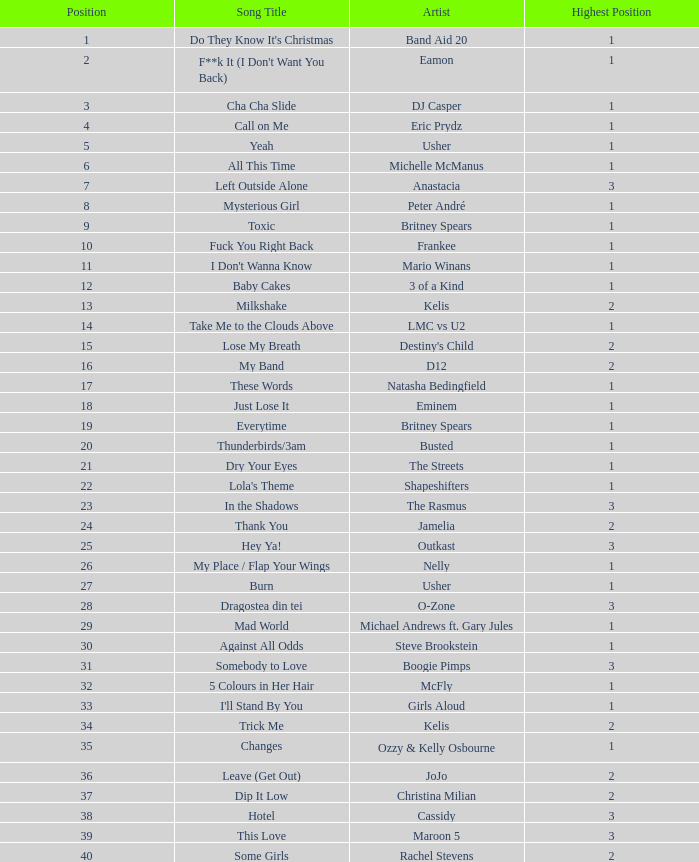What were the revenues for dj casper when he was ranked below 13? 351421.0. 